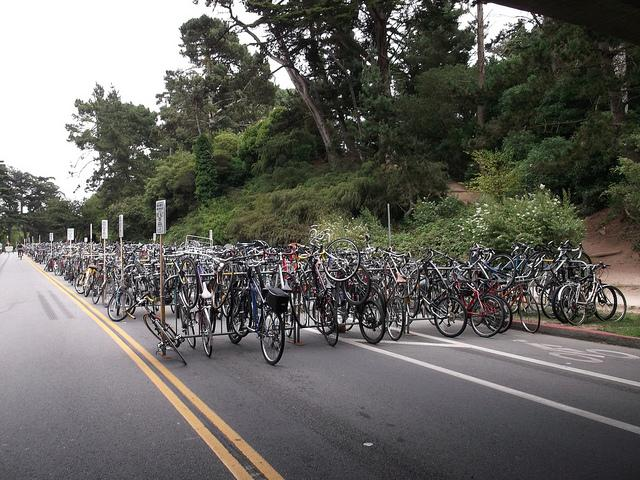What company is known for making the abundant items here?

Choices:
A) green giant
B) huffy
C) popeyes
D) mcdonalds huffy 